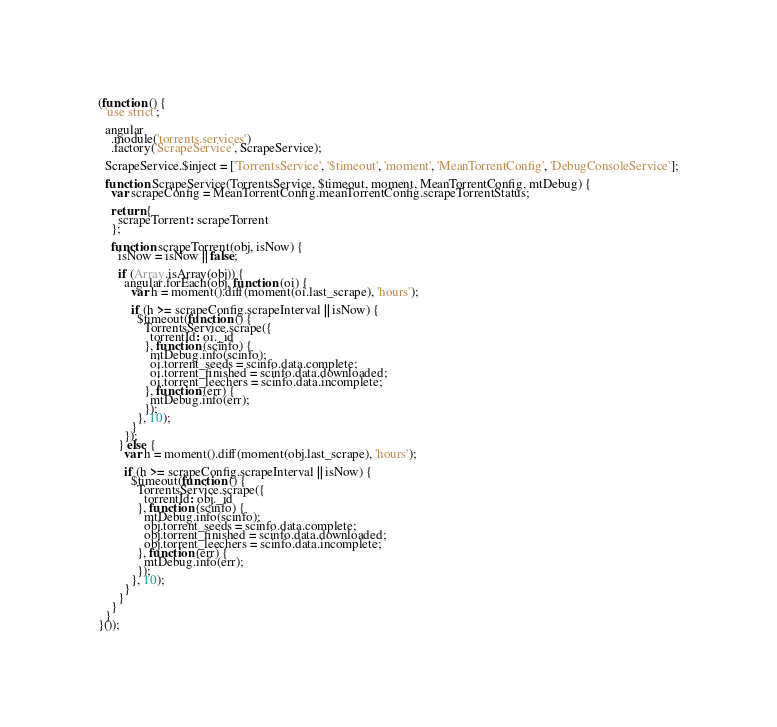<code> <loc_0><loc_0><loc_500><loc_500><_JavaScript_>(function () {
  'use strict';

  angular
    .module('torrents.services')
    .factory('ScrapeService', ScrapeService);

  ScrapeService.$inject = ['TorrentsService', '$timeout', 'moment', 'MeanTorrentConfig', 'DebugConsoleService'];

  function ScrapeService(TorrentsService, $timeout, moment, MeanTorrentConfig, mtDebug) {
    var scrapeConfig = MeanTorrentConfig.meanTorrentConfig.scrapeTorrentStatus;

    return {
      scrapeTorrent: scrapeTorrent
    };

    function scrapeTorrent(obj, isNow) {
      isNow = isNow || false;

      if (Array.isArray(obj)) {
        angular.forEach(obj, function (oi) {
          var h = moment().diff(moment(oi.last_scrape), 'hours');

          if (h >= scrapeConfig.scrapeInterval || isNow) {
            $timeout(function () {
              TorrentsService.scrape({
                torrentId: oi._id
              }, function (scinfo) {
                mtDebug.info(scinfo);
                oi.torrent_seeds = scinfo.data.complete;
                oi.torrent_finished = scinfo.data.downloaded;
                oi.torrent_leechers = scinfo.data.incomplete;
              }, function (err) {
                mtDebug.info(err);
              });
            }, 10);
          }
        });
      } else {
        var h = moment().diff(moment(obj.last_scrape), 'hours');

        if (h >= scrapeConfig.scrapeInterval || isNow) {
          $timeout(function () {
            TorrentsService.scrape({
              torrentId: obj._id
            }, function (scinfo) {
              mtDebug.info(scinfo);
              obj.torrent_seeds = scinfo.data.complete;
              obj.torrent_finished = scinfo.data.downloaded;
              obj.torrent_leechers = scinfo.data.incomplete;
            }, function (err) {
              mtDebug.info(err);
            });
          }, 10);
        }
      }
    }
  }
}());
</code> 